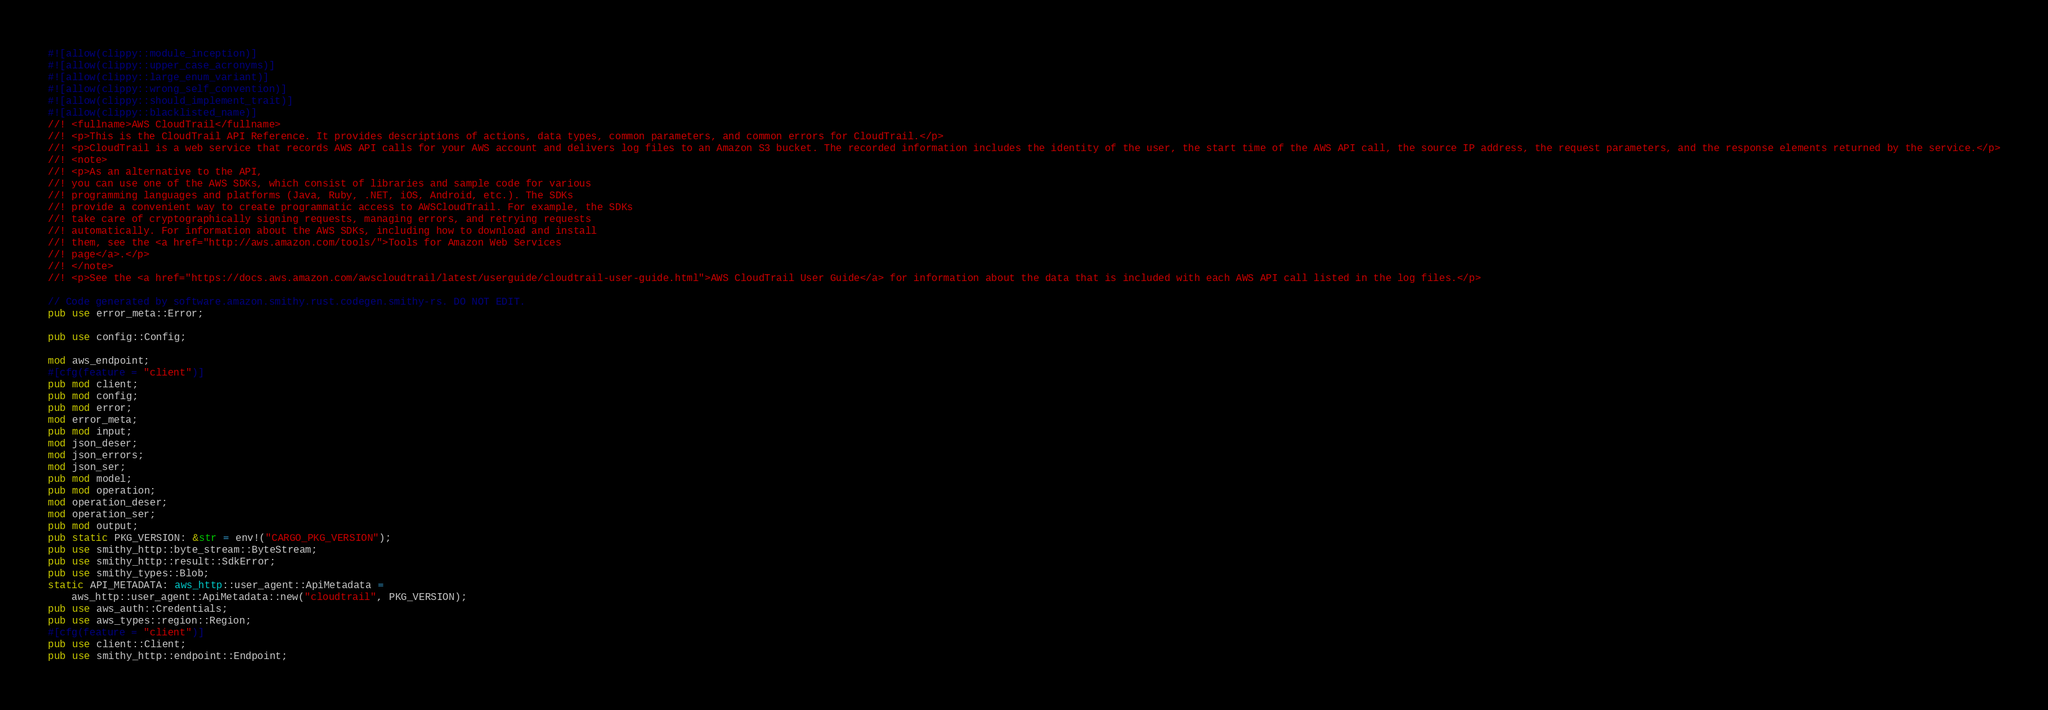Convert code to text. <code><loc_0><loc_0><loc_500><loc_500><_Rust_>#![allow(clippy::module_inception)]
#![allow(clippy::upper_case_acronyms)]
#![allow(clippy::large_enum_variant)]
#![allow(clippy::wrong_self_convention)]
#![allow(clippy::should_implement_trait)]
#![allow(clippy::blacklisted_name)]
//! <fullname>AWS CloudTrail</fullname>
//! <p>This is the CloudTrail API Reference. It provides descriptions of actions, data types, common parameters, and common errors for CloudTrail.</p>
//! <p>CloudTrail is a web service that records AWS API calls for your AWS account and delivers log files to an Amazon S3 bucket. The recorded information includes the identity of the user, the start time of the AWS API call, the source IP address, the request parameters, and the response elements returned by the service.</p>
//! <note>
//! <p>As an alternative to the API,
//! you can use one of the AWS SDKs, which consist of libraries and sample code for various
//! programming languages and platforms (Java, Ruby, .NET, iOS, Android, etc.). The SDKs
//! provide a convenient way to create programmatic access to AWSCloudTrail. For example, the SDKs
//! take care of cryptographically signing requests, managing errors, and retrying requests
//! automatically. For information about the AWS SDKs, including how to download and install
//! them, see the <a href="http://aws.amazon.com/tools/">Tools for Amazon Web Services
//! page</a>.</p>
//! </note>
//! <p>See the <a href="https://docs.aws.amazon.com/awscloudtrail/latest/userguide/cloudtrail-user-guide.html">AWS CloudTrail User Guide</a> for information about the data that is included with each AWS API call listed in the log files.</p>

// Code generated by software.amazon.smithy.rust.codegen.smithy-rs. DO NOT EDIT.
pub use error_meta::Error;

pub use config::Config;

mod aws_endpoint;
#[cfg(feature = "client")]
pub mod client;
pub mod config;
pub mod error;
mod error_meta;
pub mod input;
mod json_deser;
mod json_errors;
mod json_ser;
pub mod model;
pub mod operation;
mod operation_deser;
mod operation_ser;
pub mod output;
pub static PKG_VERSION: &str = env!("CARGO_PKG_VERSION");
pub use smithy_http::byte_stream::ByteStream;
pub use smithy_http::result::SdkError;
pub use smithy_types::Blob;
static API_METADATA: aws_http::user_agent::ApiMetadata =
    aws_http::user_agent::ApiMetadata::new("cloudtrail", PKG_VERSION);
pub use aws_auth::Credentials;
pub use aws_types::region::Region;
#[cfg(feature = "client")]
pub use client::Client;
pub use smithy_http::endpoint::Endpoint;
</code> 